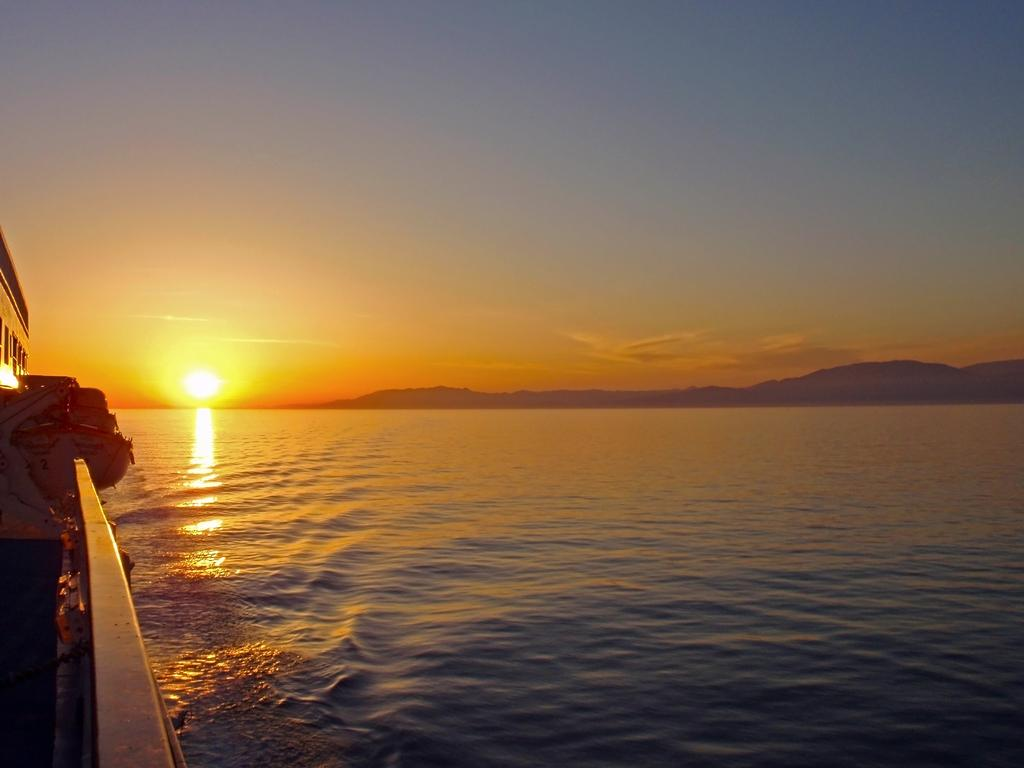What is located on the left side of the image? There is a boat on the left side of the image. What can be seen in the middle of the image? There is a river in the middle of the image. What is visible in the sky in the image? The sun is visible in the sky. What historical event is being protested in the image? There is no protest or historical event depicted in the image; it features a boat, a river, and the sun. Can you tell me how many people are in jail in the image? There are no people or jails present in the image. 